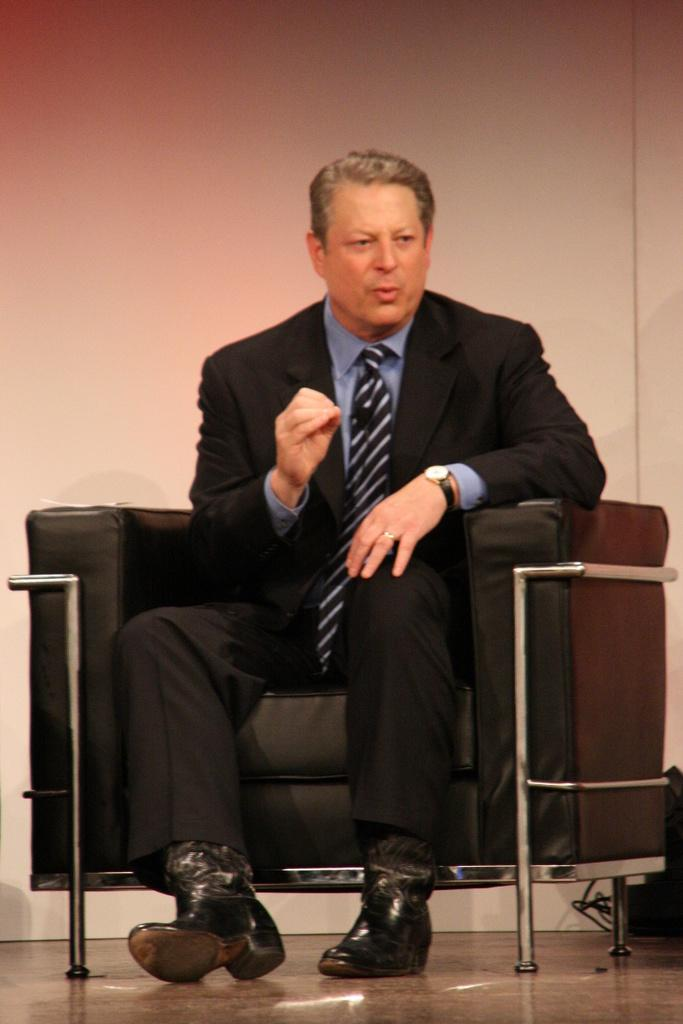Who is present in the image? There is a man in the image. What is the man wearing? The man is wearing a suit. What is the man doing in the image? The man is sitting on a sofa. What can be seen in the background of the image? There is a wall in the background of the image. Where is the playground located in the image? There is no playground present in the image. What type of cow can be seen grazing near the man in the image? There is no cow present in the image. 